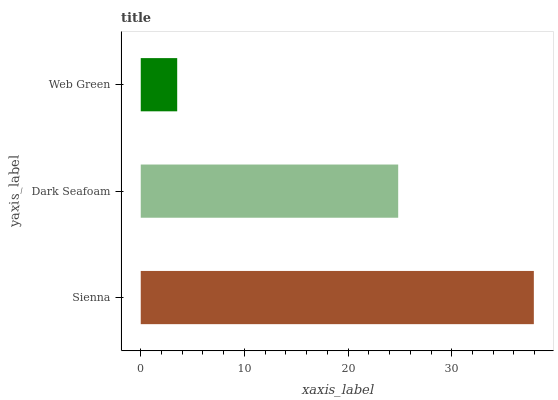Is Web Green the minimum?
Answer yes or no. Yes. Is Sienna the maximum?
Answer yes or no. Yes. Is Dark Seafoam the minimum?
Answer yes or no. No. Is Dark Seafoam the maximum?
Answer yes or no. No. Is Sienna greater than Dark Seafoam?
Answer yes or no. Yes. Is Dark Seafoam less than Sienna?
Answer yes or no. Yes. Is Dark Seafoam greater than Sienna?
Answer yes or no. No. Is Sienna less than Dark Seafoam?
Answer yes or no. No. Is Dark Seafoam the high median?
Answer yes or no. Yes. Is Dark Seafoam the low median?
Answer yes or no. Yes. Is Web Green the high median?
Answer yes or no. No. Is Web Green the low median?
Answer yes or no. No. 